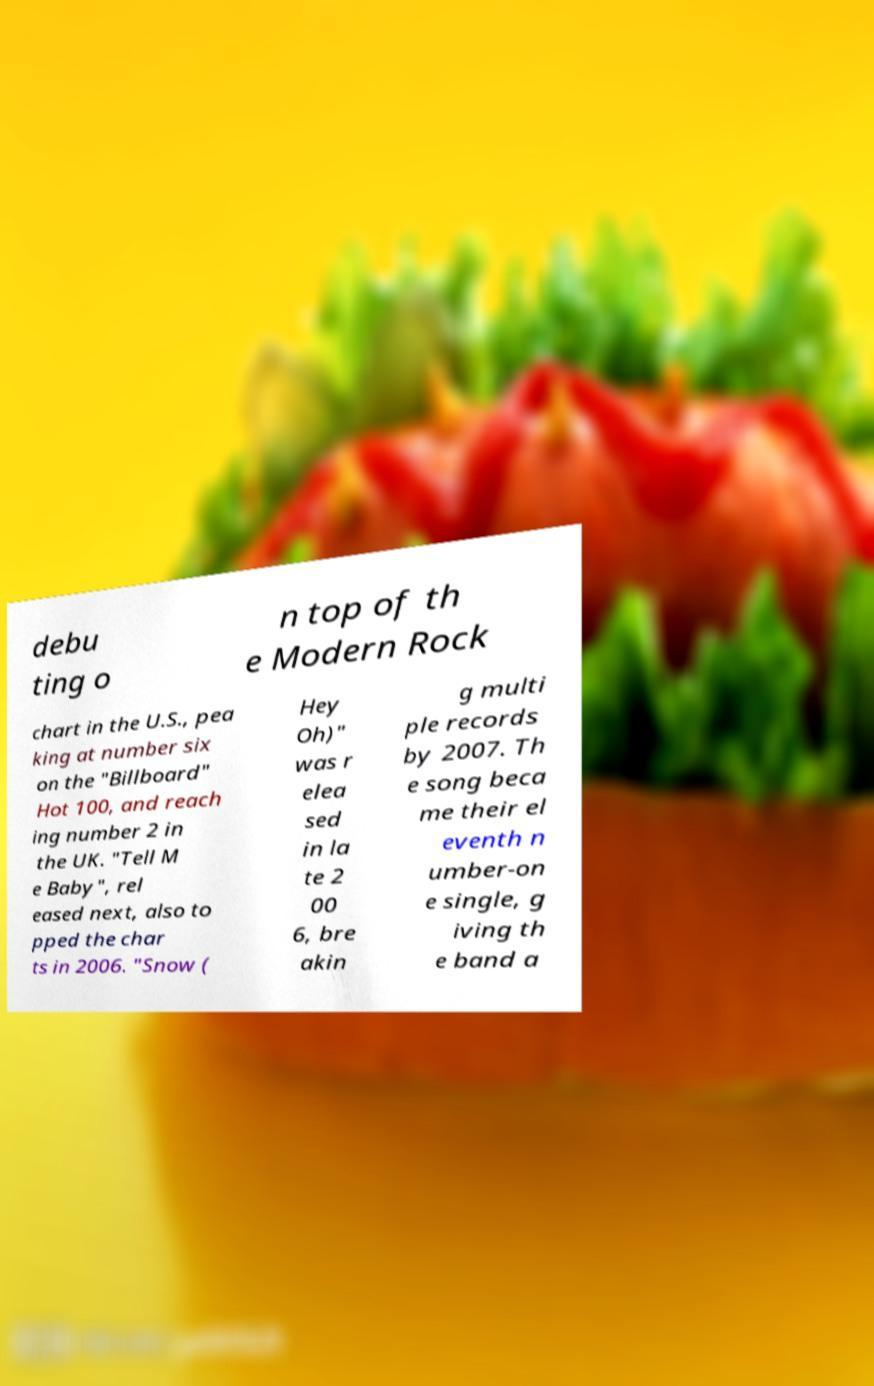I need the written content from this picture converted into text. Can you do that? debu ting o n top of th e Modern Rock chart in the U.S., pea king at number six on the "Billboard" Hot 100, and reach ing number 2 in the UK. "Tell M e Baby", rel eased next, also to pped the char ts in 2006. "Snow ( Hey Oh)" was r elea sed in la te 2 00 6, bre akin g multi ple records by 2007. Th e song beca me their el eventh n umber-on e single, g iving th e band a 